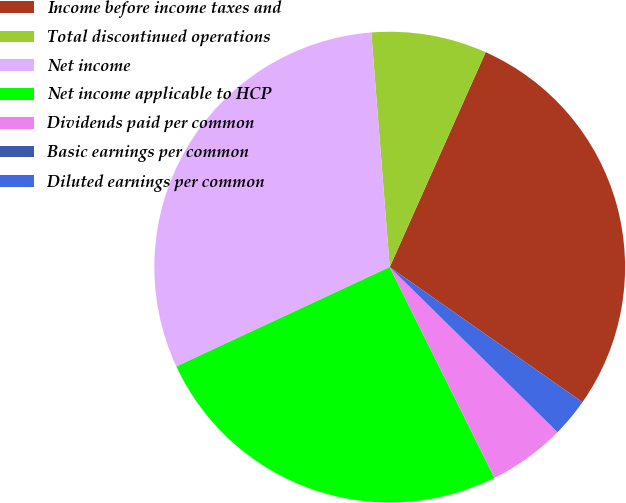<chart> <loc_0><loc_0><loc_500><loc_500><pie_chart><fcel>Income before income taxes and<fcel>Total discontinued operations<fcel>Net income<fcel>Net income applicable to HCP<fcel>Dividends paid per common<fcel>Basic earnings per common<fcel>Diluted earnings per common<nl><fcel>28.04%<fcel>7.93%<fcel>30.69%<fcel>25.4%<fcel>5.29%<fcel>0.0%<fcel>2.64%<nl></chart> 